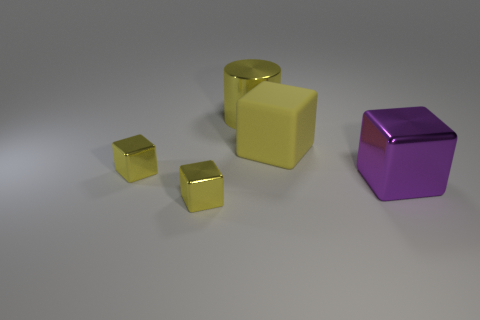Do the matte cube and the cylinder have the same color?
Your answer should be compact. Yes. Are there fewer purple shiny blocks that are on the left side of the large purple metal thing than big rubber objects that are to the right of the big matte object?
Your response must be concise. No. There is a large rubber thing that is the same shape as the big purple metallic object; what color is it?
Provide a short and direct response. Yellow. There is a yellow metallic cylinder to the left of the purple block; does it have the same size as the large yellow matte cube?
Offer a very short reply. Yes. Is the number of purple metal objects that are in front of the yellow rubber object less than the number of yellow metallic objects?
Offer a terse response. Yes. Is there any other thing that is the same size as the yellow matte block?
Offer a terse response. Yes. There is a yellow object behind the big block that is behind the large purple metallic block; how big is it?
Provide a short and direct response. Large. Are there any other things that are the same shape as the large purple shiny thing?
Give a very brief answer. Yes. Are there fewer yellow cubes than big yellow shiny balls?
Give a very brief answer. No. The block that is on the right side of the big cylinder and in front of the matte cube is made of what material?
Provide a short and direct response. Metal. 